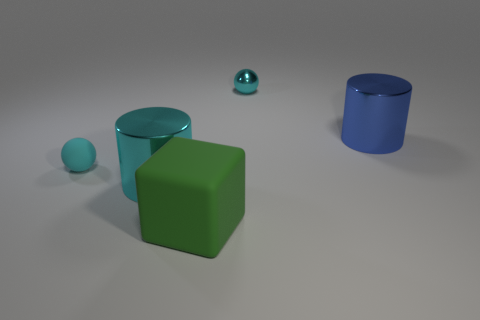Is the number of large rubber objects that are to the left of the cyan shiny cylinder less than the number of tiny things?
Provide a short and direct response. Yes. Does the tiny rubber ball have the same color as the metallic ball?
Provide a short and direct response. Yes. What is the size of the blue cylinder?
Your answer should be compact. Large. How many shiny cylinders are the same color as the small metallic sphere?
Offer a terse response. 1. There is a shiny cylinder that is behind the large metallic object that is to the left of the large rubber thing; are there any big blue cylinders that are in front of it?
Give a very brief answer. No. There is a cyan object that is the same size as the matte ball; what is its shape?
Make the answer very short. Sphere. How many large objects are either shiny things or blue metallic things?
Your response must be concise. 2. There is a big cylinder that is the same material as the big blue thing; what color is it?
Your answer should be compact. Cyan. There is a object behind the blue cylinder; is it the same shape as the tiny thing on the left side of the large green thing?
Provide a short and direct response. Yes. How many metal things are cyan spheres or tiny purple spheres?
Offer a terse response. 1. 